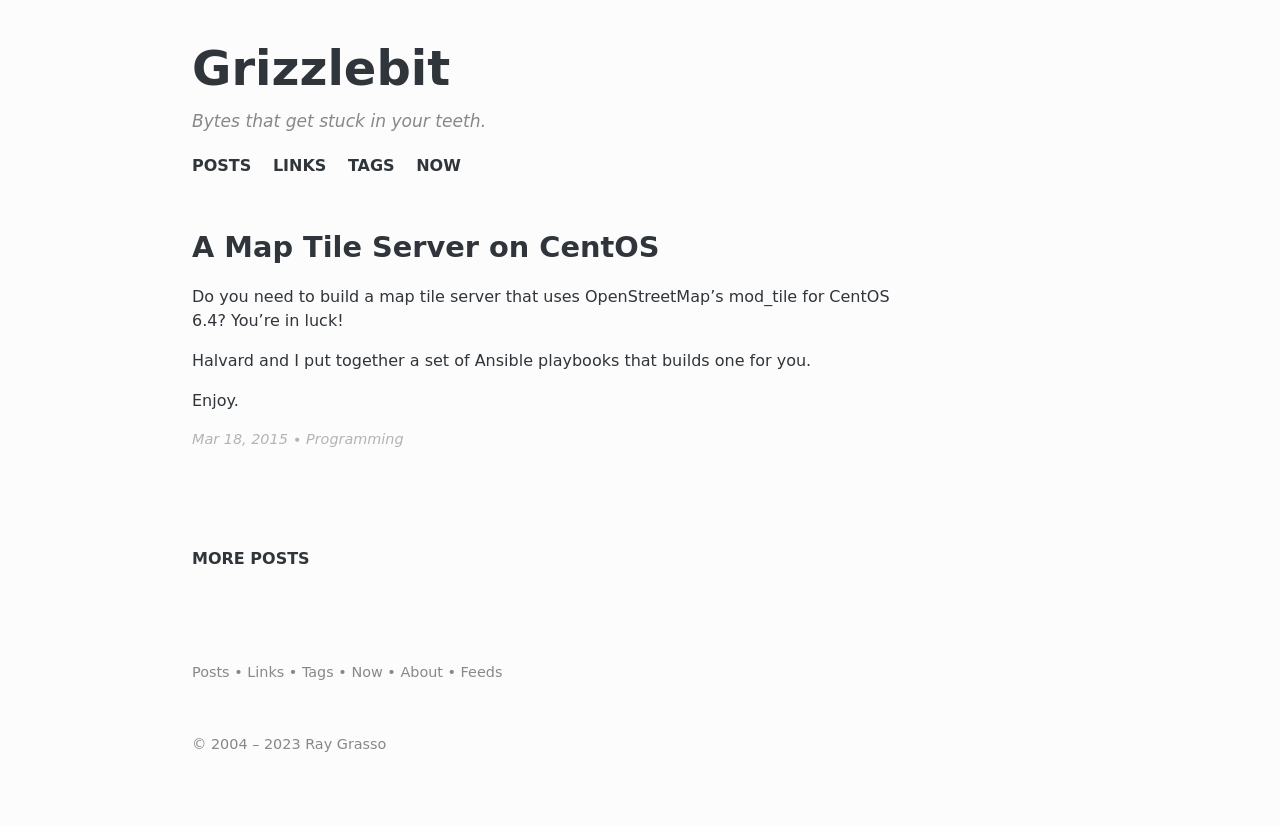Why might someone choose to build a map tile server, as mentioned in the main article of this website? Someone might build a map tile server to have control over map styling and data, to handle high levels of traffic without depending on third-party services, and to customize the maps for specific applications. It also reduces reliance on outside map providers, which may have cost or usage restrictions.  What are some considerations when selecting fonts for a website as shown in this design? When selecting fonts for a website, consider readability, web compatibility, and overall aesthetic harmony with the site's design. The font should align with the brand's image, be easily legible on various devices and screen sizes, and ideally load efficiently to improve website performance. License and usage rights are also important factors to consider. 